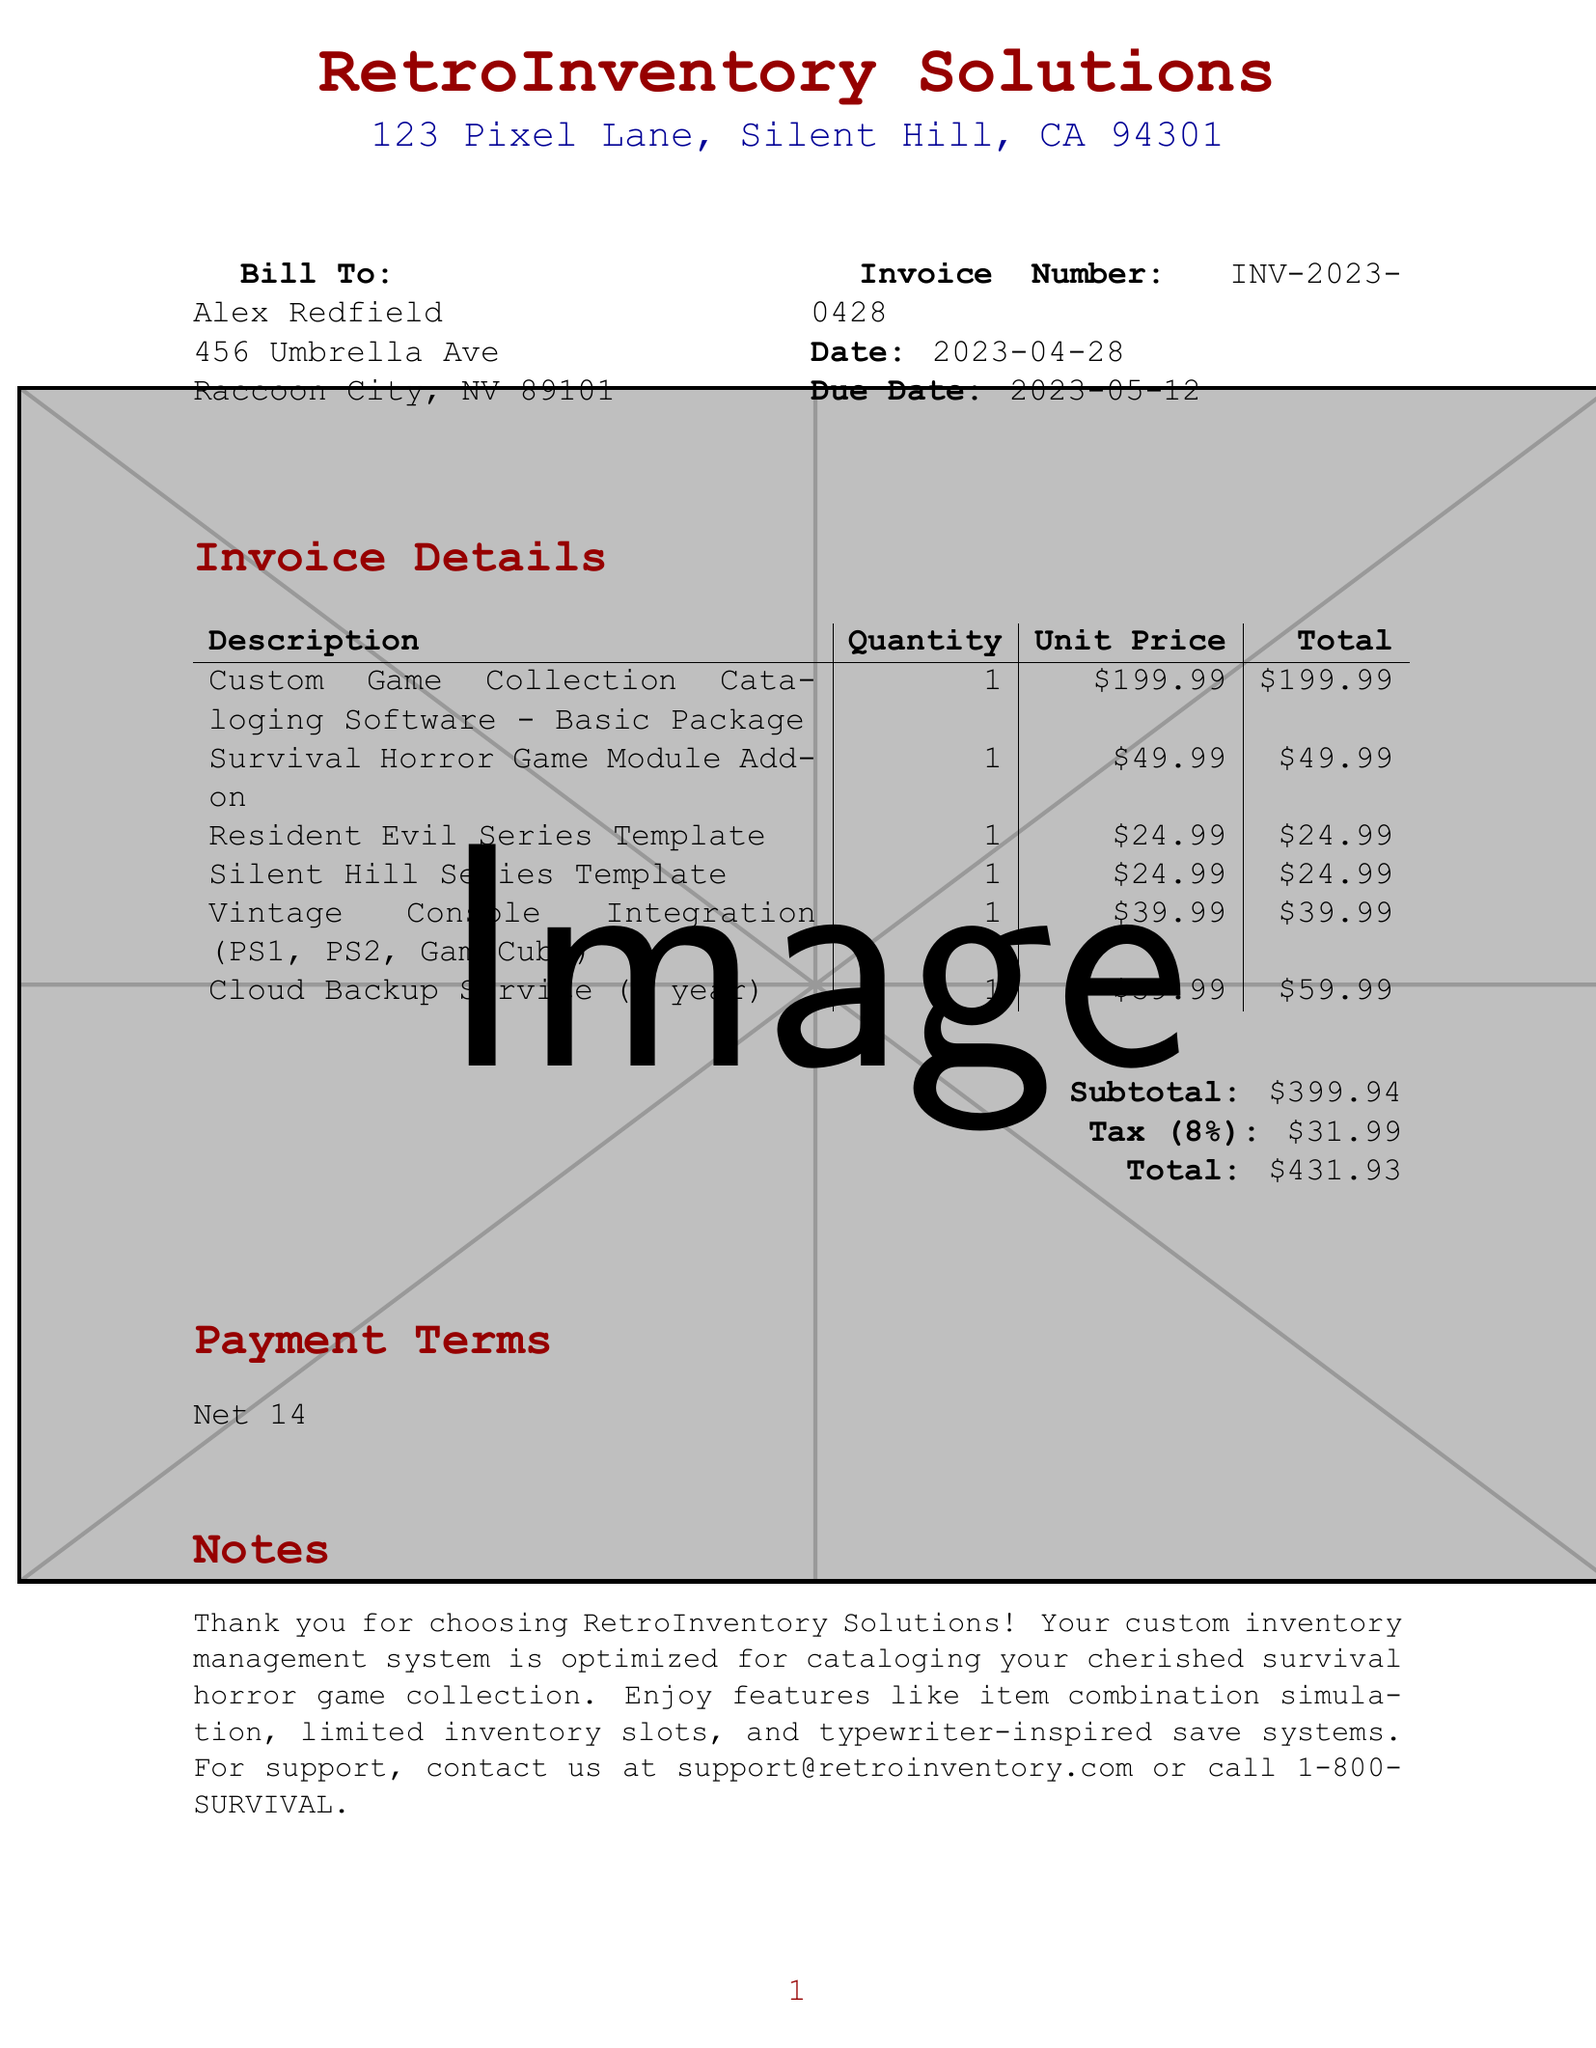What is the invoice number? The invoice number is clearly stated in the document as the unique identifier for this transaction.
Answer: INV-2023-0428 What is the due date for payment? The due date is specified in the document, indicating when the payment must be made.
Answer: 2023-05-12 Who is the client? The document identifies the client receiving the invoice, including their name and address.
Answer: Alex Redfield What is the total amount due? The total amount due is calculated and highlighted in the document as the final figure that needs to be paid.
Answer: 431.93 How many different software modules are listed? Counting the items in the invoice provides the number of distinct offerings for the client.
Answer: 6 What is the tax rate applied? The tax rate is mentioned in the document, specifying the percentage applied to the subtotal.
Answer: 8% What type of service is included for backup? A specific service related to data protection and preservation is mentioned in the document.
Answer: Cloud Backup Service What is the payment term given in the invoice? The payment terms describe how long the client has to pay before the invoice is considered late.
Answer: Net 14 What is included in the Survival Horror Game Module Add-on? The add-on is likely mentioned with its benefits or features but is not explicitly detailed here.
Answer: Survival Horror Game Module Add-on 